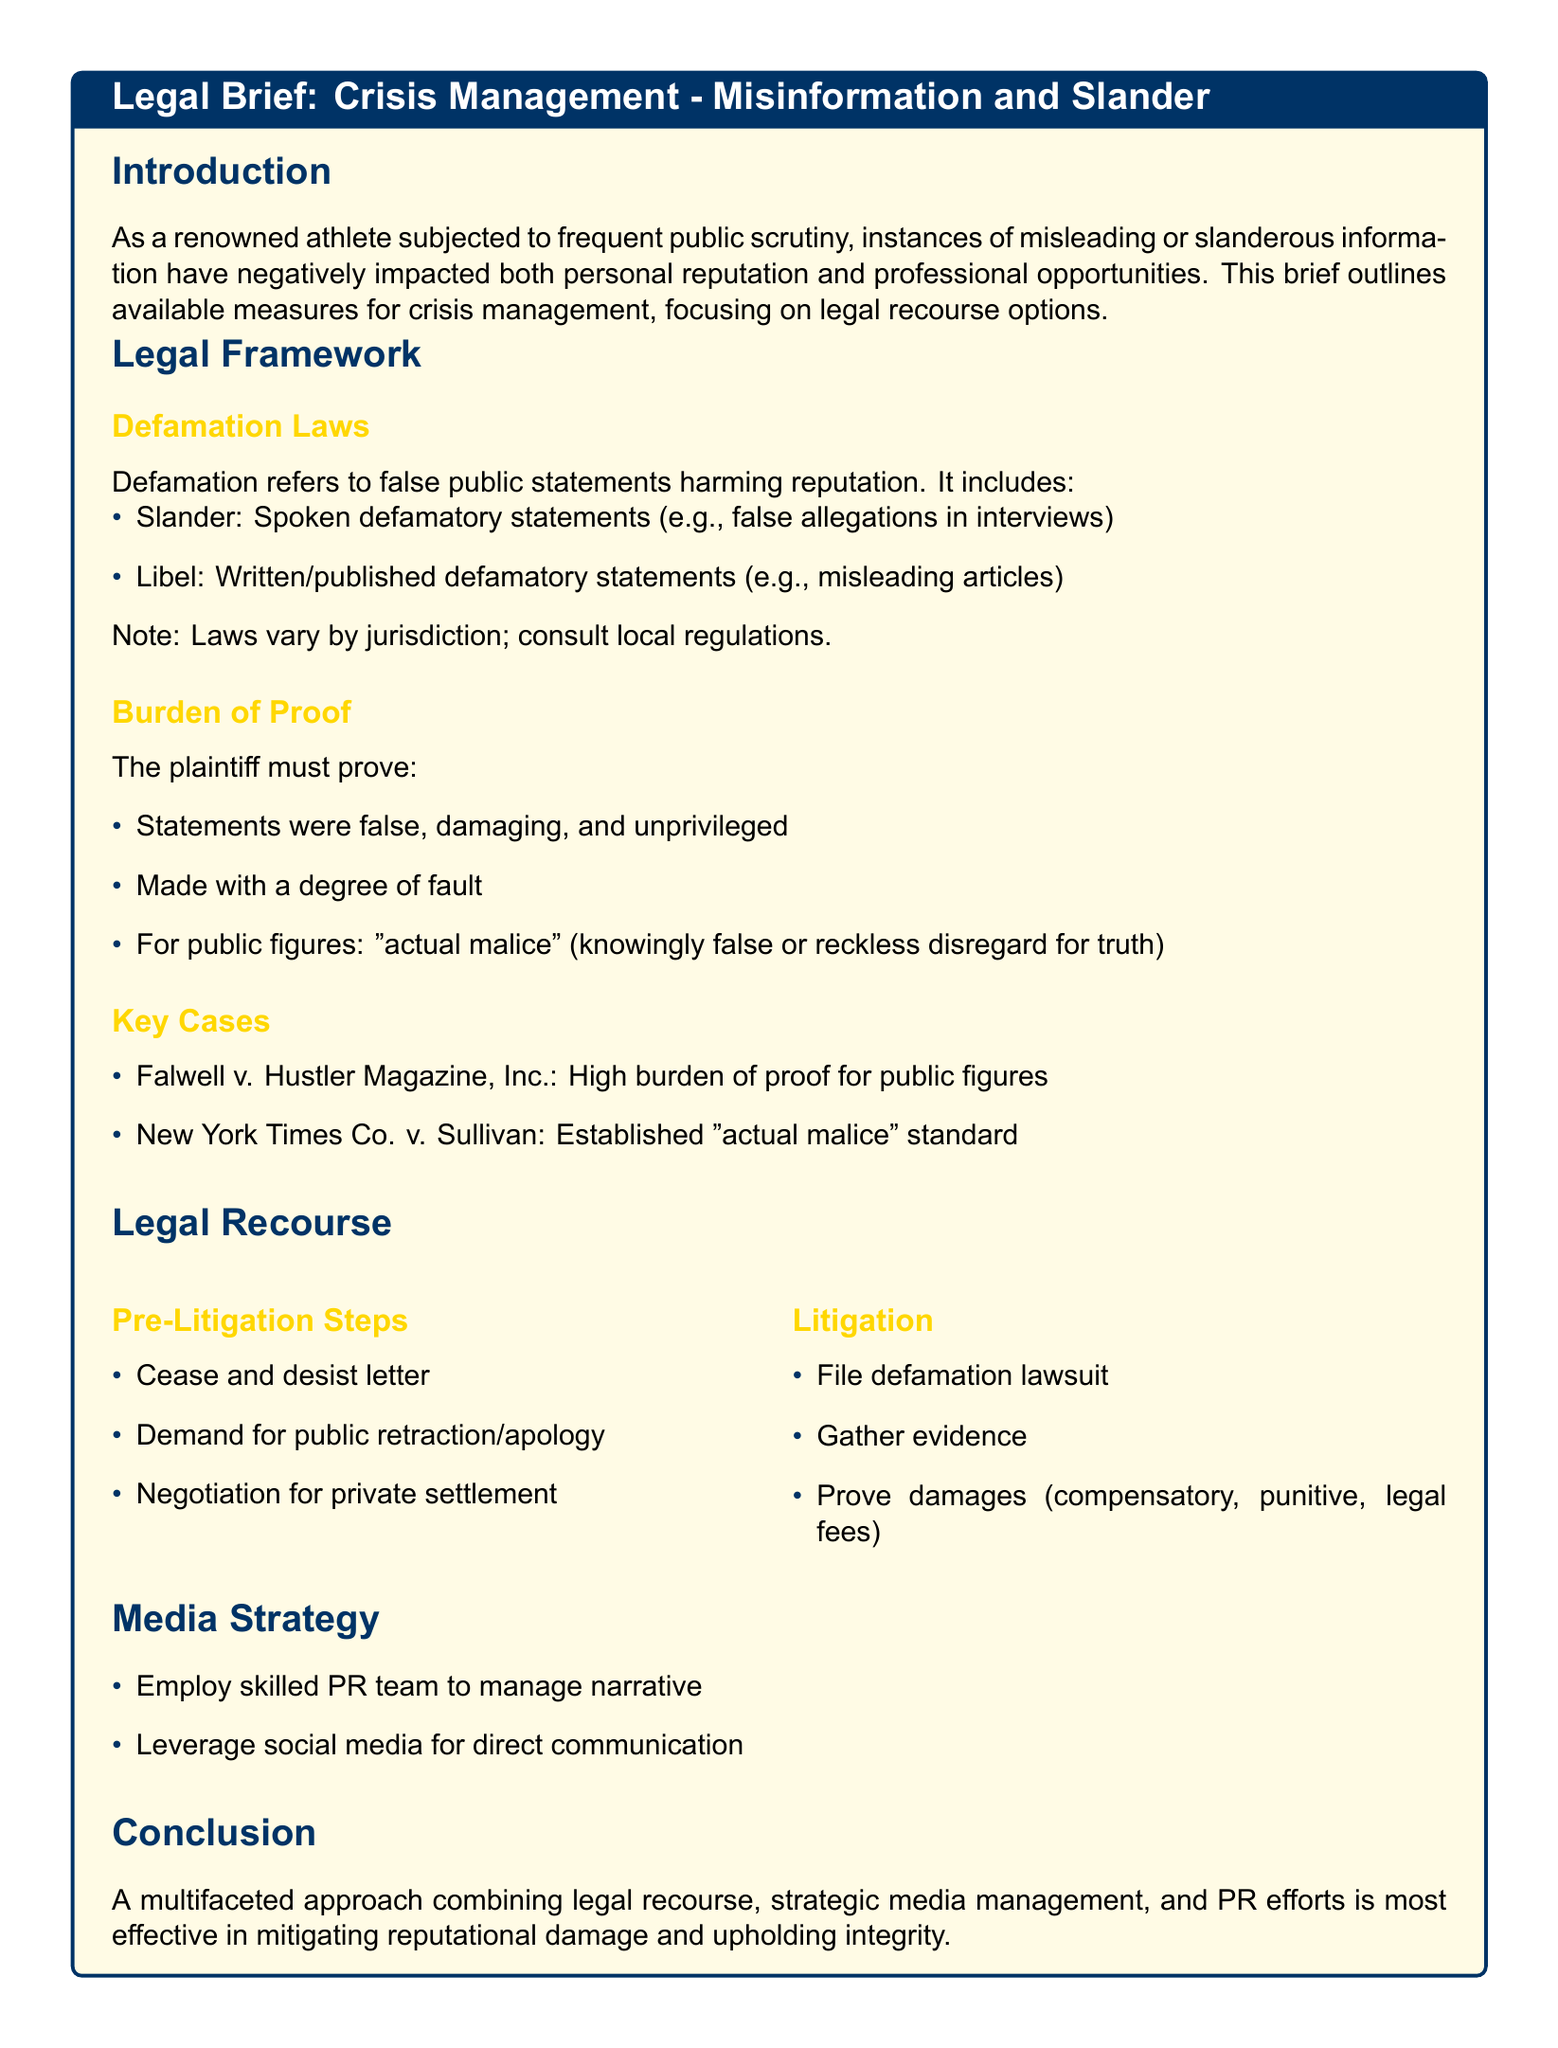What is the subject of the legal brief? The subject of the legal brief, as stated in the title, is Crisis Management: Misinformation and Slander.
Answer: Crisis Management: Misinformation and Slander What does defamation include? The document states that defamation includes slander and libel.
Answer: Slander and libel What must the plaintiff prove in a defamation case? The plaintiff must prove that statements were false, damaging, unprivileged, made with fault, and for public figures, actual malice.
Answer: False, damaging, unprivileged, fault, actual malice Which case established the "actual malice" standard? The document mentions New York Times Co. v. Sullivan as the case that established this standard.
Answer: New York Times Co. v. Sullivan What is the first pre-litigation step recommended? The first pre-litigation step suggested is to send a cease and desist letter.
Answer: Cease and desist letter What is a key strategy for media management mentioned in the brief? The brief suggests employing a skilled PR team to manage the narrative.
Answer: Skilled PR team How many steps are listed under litigation? There are three steps listed under litigation: filing a lawsuit, gathering evidence, and proving damages.
Answer: Three steps What is the main goal of the conclusion in the document? The conclusion emphasizes the effectiveness of a multifaceted approach combining legal recourse and media management.
Answer: Multifaceted approach What color is used for the section titles in the document? The section titles in the document are styled with athlete blue.
Answer: Athlete blue 